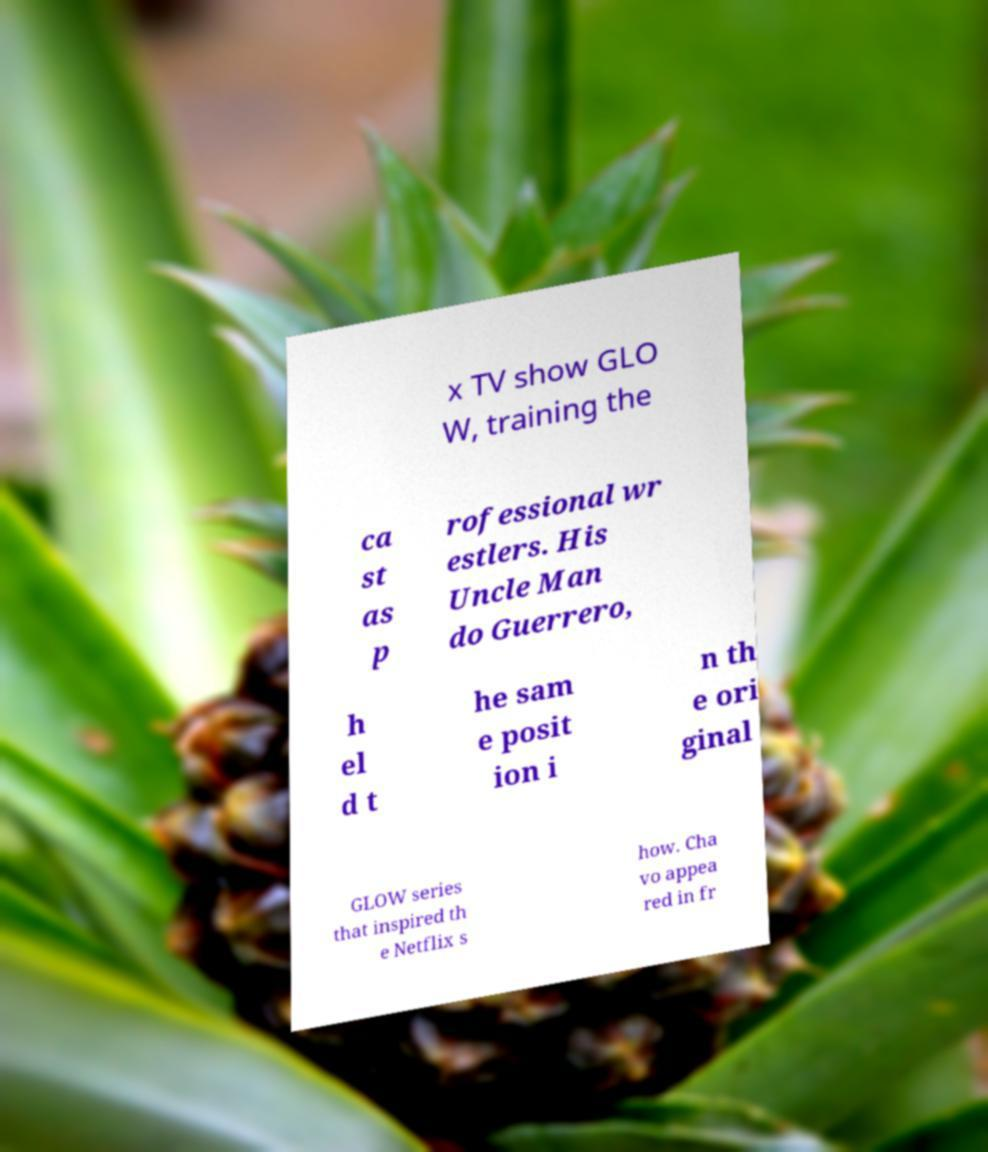Could you extract and type out the text from this image? x TV show GLO W, training the ca st as p rofessional wr estlers. His Uncle Man do Guerrero, h el d t he sam e posit ion i n th e ori ginal GLOW series that inspired th e Netflix s how. Cha vo appea red in fr 